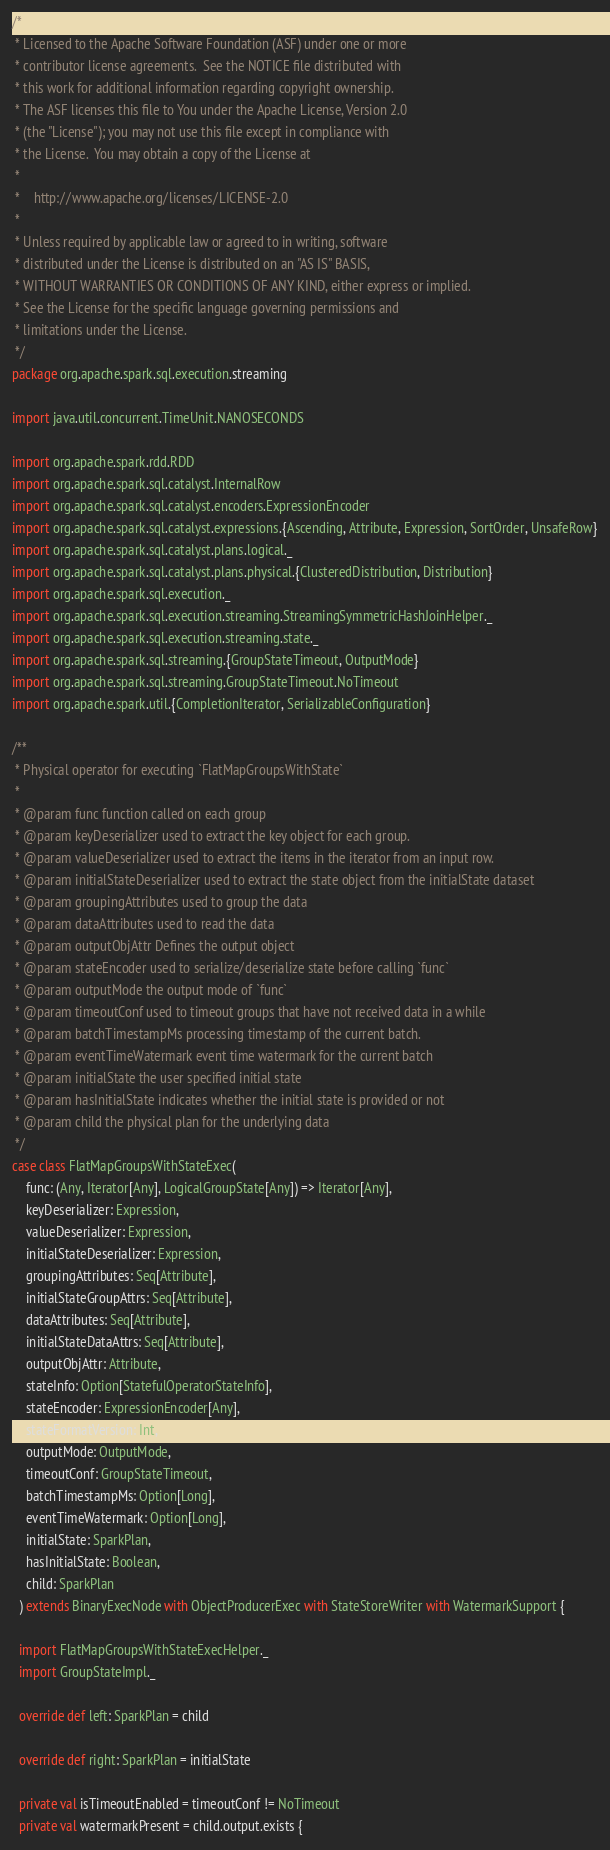Convert code to text. <code><loc_0><loc_0><loc_500><loc_500><_Scala_>/*
 * Licensed to the Apache Software Foundation (ASF) under one or more
 * contributor license agreements.  See the NOTICE file distributed with
 * this work for additional information regarding copyright ownership.
 * The ASF licenses this file to You under the Apache License, Version 2.0
 * (the "License"); you may not use this file except in compliance with
 * the License.  You may obtain a copy of the License at
 *
 *    http://www.apache.org/licenses/LICENSE-2.0
 *
 * Unless required by applicable law or agreed to in writing, software
 * distributed under the License is distributed on an "AS IS" BASIS,
 * WITHOUT WARRANTIES OR CONDITIONS OF ANY KIND, either express or implied.
 * See the License for the specific language governing permissions and
 * limitations under the License.
 */
package org.apache.spark.sql.execution.streaming

import java.util.concurrent.TimeUnit.NANOSECONDS

import org.apache.spark.rdd.RDD
import org.apache.spark.sql.catalyst.InternalRow
import org.apache.spark.sql.catalyst.encoders.ExpressionEncoder
import org.apache.spark.sql.catalyst.expressions.{Ascending, Attribute, Expression, SortOrder, UnsafeRow}
import org.apache.spark.sql.catalyst.plans.logical._
import org.apache.spark.sql.catalyst.plans.physical.{ClusteredDistribution, Distribution}
import org.apache.spark.sql.execution._
import org.apache.spark.sql.execution.streaming.StreamingSymmetricHashJoinHelper._
import org.apache.spark.sql.execution.streaming.state._
import org.apache.spark.sql.streaming.{GroupStateTimeout, OutputMode}
import org.apache.spark.sql.streaming.GroupStateTimeout.NoTimeout
import org.apache.spark.util.{CompletionIterator, SerializableConfiguration}

/**
 * Physical operator for executing `FlatMapGroupsWithState`
 *
 * @param func function called on each group
 * @param keyDeserializer used to extract the key object for each group.
 * @param valueDeserializer used to extract the items in the iterator from an input row.
 * @param initialStateDeserializer used to extract the state object from the initialState dataset
 * @param groupingAttributes used to group the data
 * @param dataAttributes used to read the data
 * @param outputObjAttr Defines the output object
 * @param stateEncoder used to serialize/deserialize state before calling `func`
 * @param outputMode the output mode of `func`
 * @param timeoutConf used to timeout groups that have not received data in a while
 * @param batchTimestampMs processing timestamp of the current batch.
 * @param eventTimeWatermark event time watermark for the current batch
 * @param initialState the user specified initial state
 * @param hasInitialState indicates whether the initial state is provided or not
 * @param child the physical plan for the underlying data
 */
case class FlatMapGroupsWithStateExec(
    func: (Any, Iterator[Any], LogicalGroupState[Any]) => Iterator[Any],
    keyDeserializer: Expression,
    valueDeserializer: Expression,
    initialStateDeserializer: Expression,
    groupingAttributes: Seq[Attribute],
    initialStateGroupAttrs: Seq[Attribute],
    dataAttributes: Seq[Attribute],
    initialStateDataAttrs: Seq[Attribute],
    outputObjAttr: Attribute,
    stateInfo: Option[StatefulOperatorStateInfo],
    stateEncoder: ExpressionEncoder[Any],
    stateFormatVersion: Int,
    outputMode: OutputMode,
    timeoutConf: GroupStateTimeout,
    batchTimestampMs: Option[Long],
    eventTimeWatermark: Option[Long],
    initialState: SparkPlan,
    hasInitialState: Boolean,
    child: SparkPlan
  ) extends BinaryExecNode with ObjectProducerExec with StateStoreWriter with WatermarkSupport {

  import FlatMapGroupsWithStateExecHelper._
  import GroupStateImpl._

  override def left: SparkPlan = child

  override def right: SparkPlan = initialState

  private val isTimeoutEnabled = timeoutConf != NoTimeout
  private val watermarkPresent = child.output.exists {</code> 